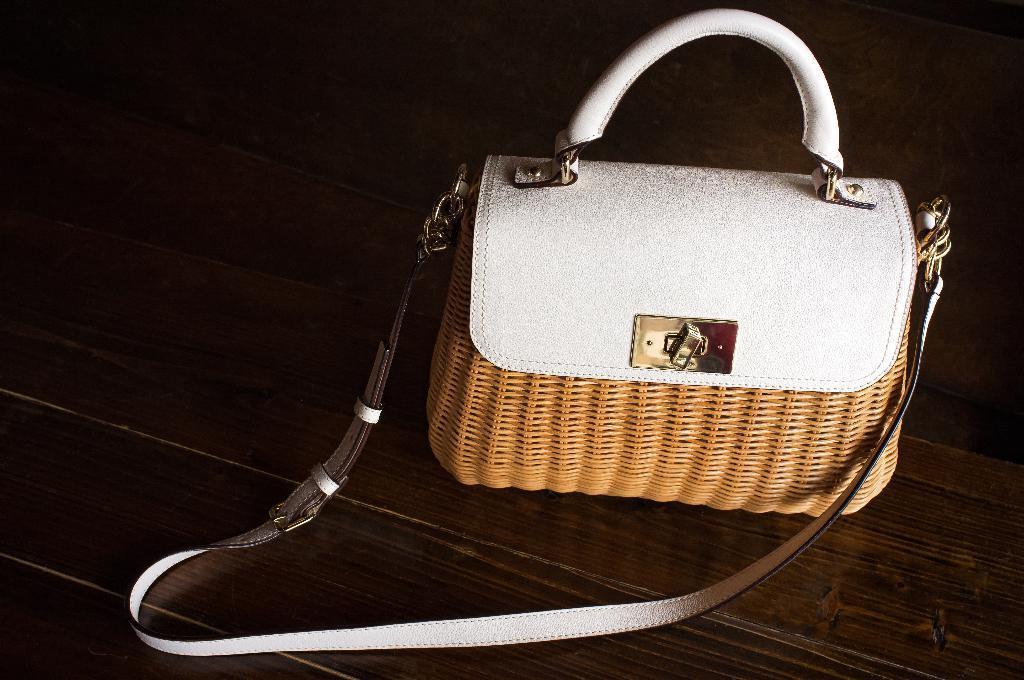Describe this image in one or two sentences. In this image there is a leather handbag in a table. 